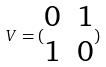<formula> <loc_0><loc_0><loc_500><loc_500>V = ( \begin{matrix} 0 & 1 \\ 1 & 0 \end{matrix} )</formula> 